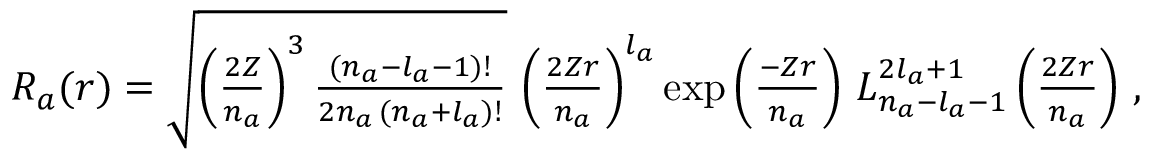<formula> <loc_0><loc_0><loc_500><loc_500>\begin{array} { r } { R _ { a } ( r ) = \sqrt { \left ( \frac { 2 Z } { n _ { a } } \right ) ^ { 3 } \frac { ( n _ { a } - l _ { a } - 1 ) ! } { 2 n _ { a } \, ( n _ { a } + l _ { a } ) ! } } \, \left ( \frac { 2 Z r } { n _ { a } } \right ) ^ { l _ { a } } \exp \left ( \frac { - Z r } { n _ { a } } \right ) \, L _ { n _ { a } - l _ { a } - 1 } ^ { 2 l _ { a } + 1 } \left ( \frac { 2 Z r } { n _ { a } } \right ) \, , } \end{array}</formula> 